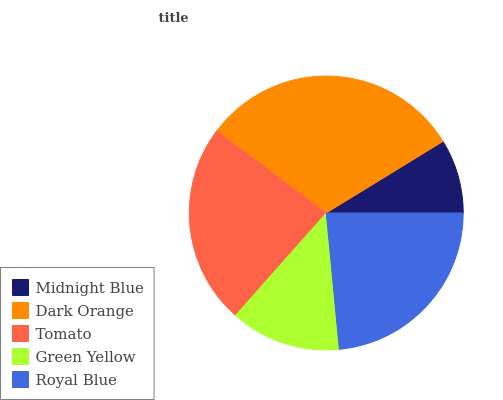Is Midnight Blue the minimum?
Answer yes or no. Yes. Is Dark Orange the maximum?
Answer yes or no. Yes. Is Tomato the minimum?
Answer yes or no. No. Is Tomato the maximum?
Answer yes or no. No. Is Dark Orange greater than Tomato?
Answer yes or no. Yes. Is Tomato less than Dark Orange?
Answer yes or no. Yes. Is Tomato greater than Dark Orange?
Answer yes or no. No. Is Dark Orange less than Tomato?
Answer yes or no. No. Is Royal Blue the high median?
Answer yes or no. Yes. Is Royal Blue the low median?
Answer yes or no. Yes. Is Midnight Blue the high median?
Answer yes or no. No. Is Midnight Blue the low median?
Answer yes or no. No. 